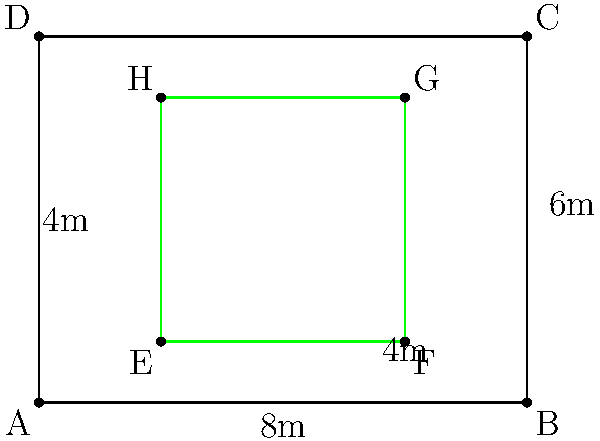You're planning to set up a green screen in your studio for your upcoming film project. The studio room measures 8m long and 6m wide. You want to leave a 2m space on all sides for equipment and crew movement. What is the area of the largest rectangular green screen you can set up in this space? Let's approach this step-by-step:

1) The room dimensions are 8m x 6m.

2) We need to leave a 2m space on all sides. This means:
   - The length of the green screen will be 8m - (2m + 2m) = 4m
   - The width of the green screen will be 6m - (2m + 2m) = 2m

3) To calculate the area of a rectangle, we use the formula:
   $$ A = l \times w $$
   Where $A$ is the area, $l$ is the length, and $w$ is the width.

4) Substituting our values:
   $$ A = 4m \times 2m = 8m^2 $$

Therefore, the area of the largest rectangular green screen that can be set up in this space is 8 square meters.
Answer: $8m^2$ 